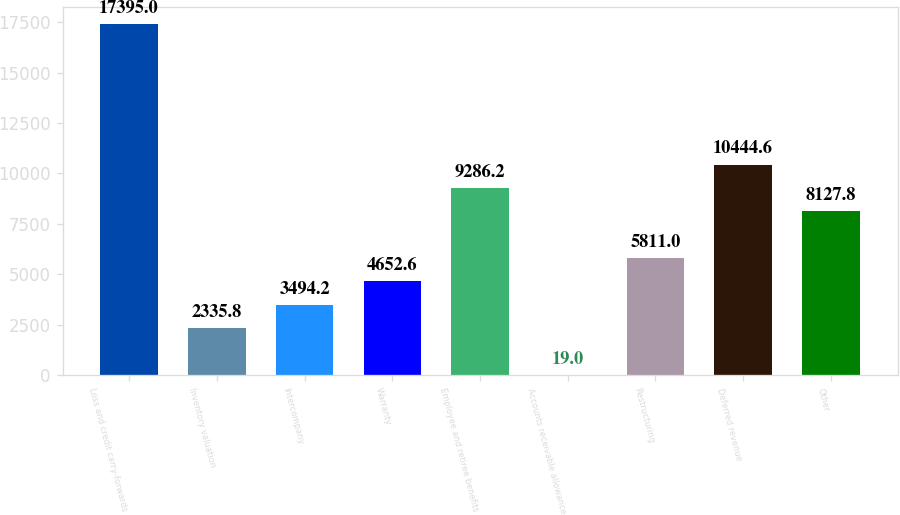Convert chart to OTSL. <chart><loc_0><loc_0><loc_500><loc_500><bar_chart><fcel>Loss and credit carry-forwards<fcel>Inventory valuation<fcel>Intercompany<fcel>Warranty<fcel>Employee and retiree benefits<fcel>Accounts receivable allowance<fcel>Restructuring<fcel>Deferred revenue<fcel>Other<nl><fcel>17395<fcel>2335.8<fcel>3494.2<fcel>4652.6<fcel>9286.2<fcel>19<fcel>5811<fcel>10444.6<fcel>8127.8<nl></chart> 